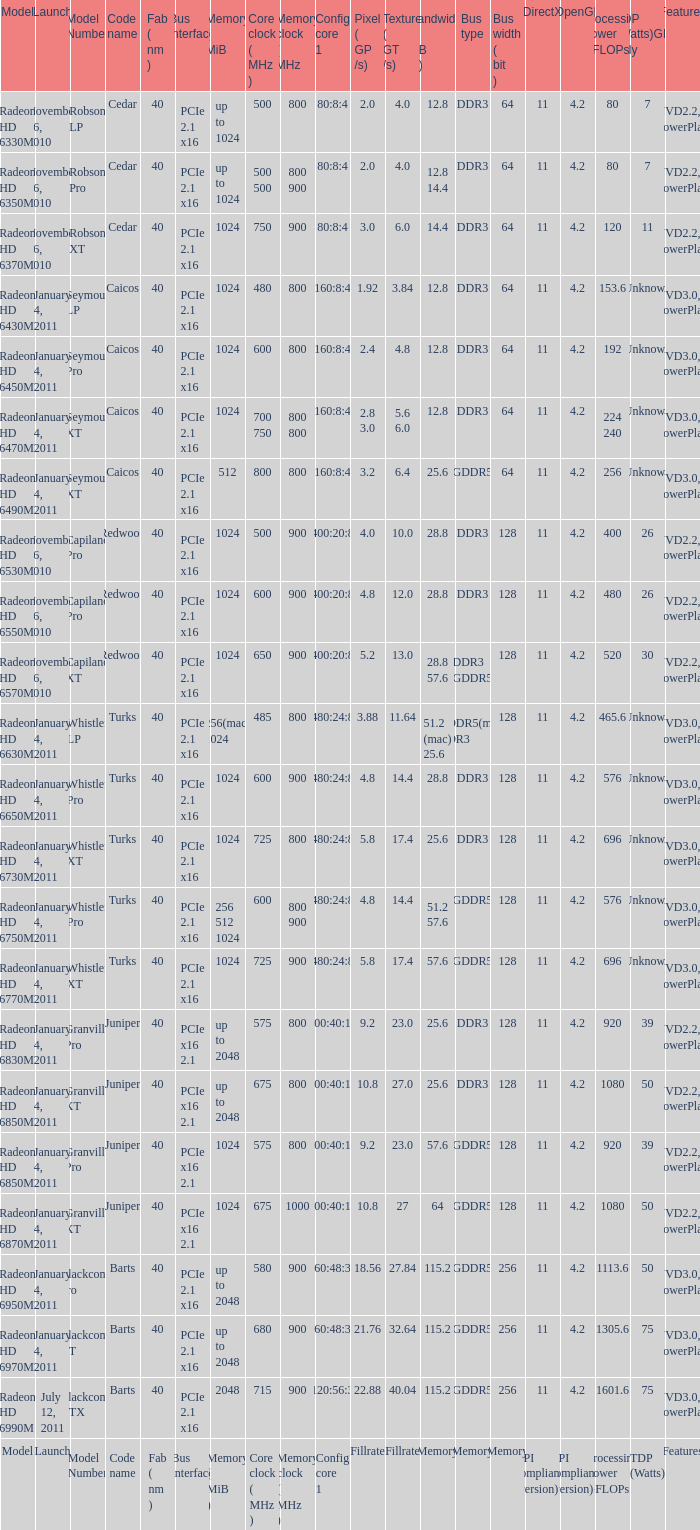What are the possible bus width values for a granville pro model with a bandwidth of 25.6? 1.0. 